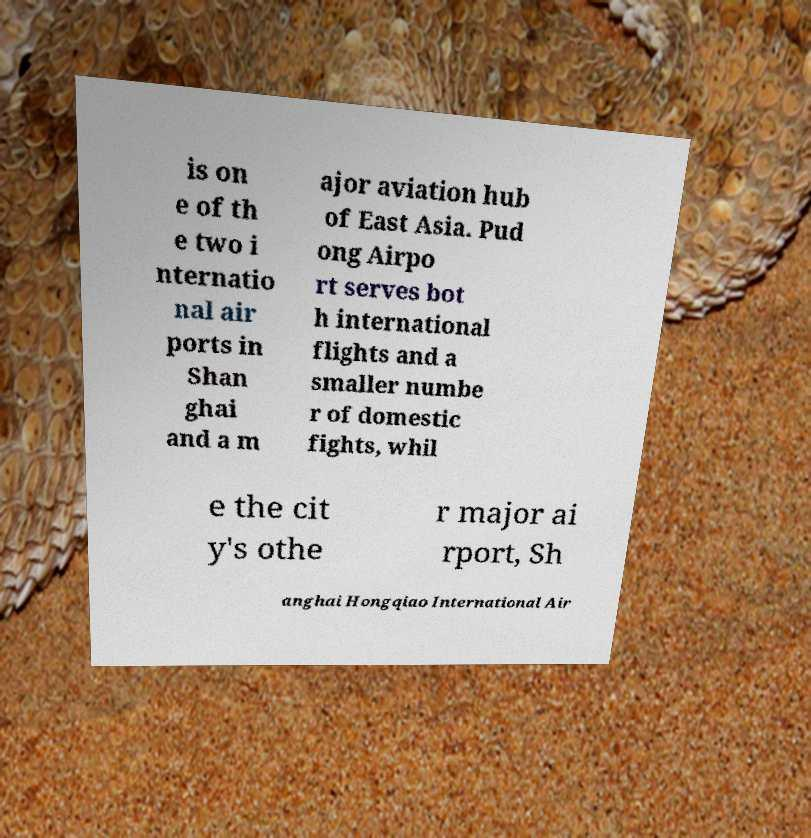Please identify and transcribe the text found in this image. is on e of th e two i nternatio nal air ports in Shan ghai and a m ajor aviation hub of East Asia. Pud ong Airpo rt serves bot h international flights and a smaller numbe r of domestic fights, whil e the cit y's othe r major ai rport, Sh anghai Hongqiao International Air 